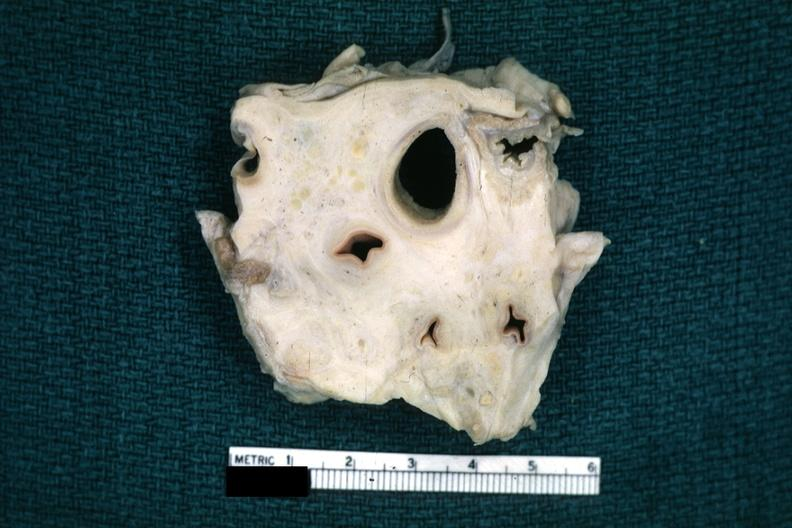s close-up tumor present?
Answer the question using a single word or phrase. No 